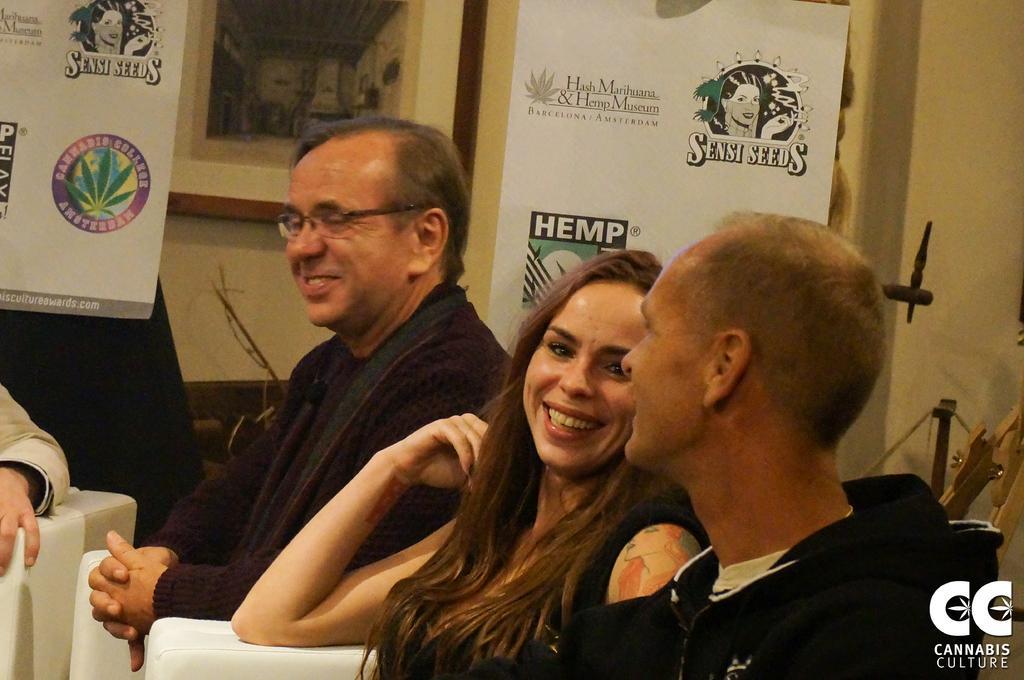How would you summarize this image in a sentence or two? This picture is clicked inside. On the right we can see the group of persons sitting on the chairs and smiling. In the background there is a wall and we can see the banners on which we can see the picture of some persons and the text is printed. In the background we can see there are some objects. In the bottom right corner there is a text on the image. 